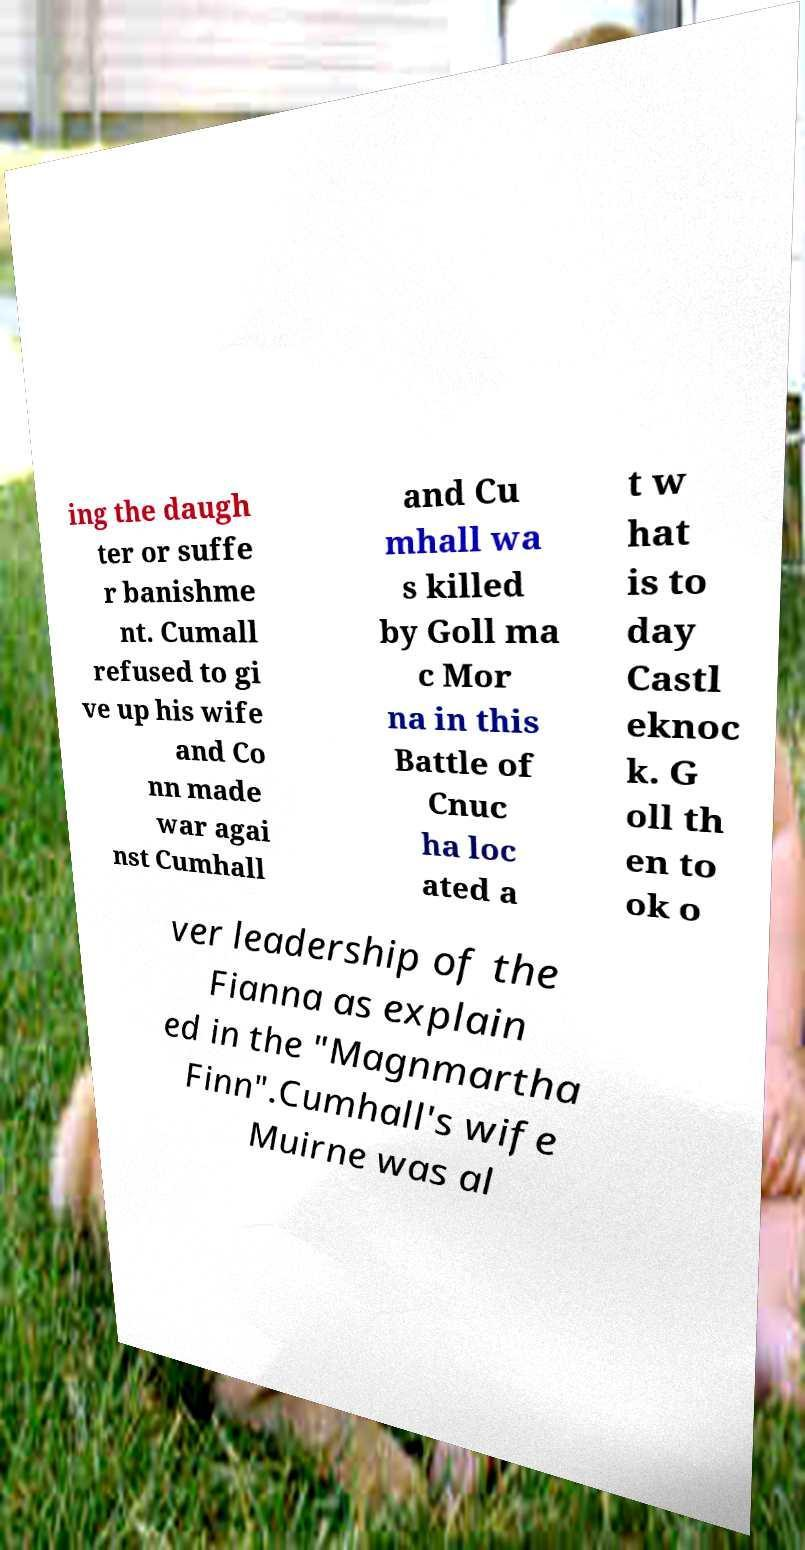There's text embedded in this image that I need extracted. Can you transcribe it verbatim? ing the daugh ter or suffe r banishme nt. Cumall refused to gi ve up his wife and Co nn made war agai nst Cumhall and Cu mhall wa s killed by Goll ma c Mor na in this Battle of Cnuc ha loc ated a t w hat is to day Castl eknoc k. G oll th en to ok o ver leadership of the Fianna as explain ed in the "Magnmartha Finn".Cumhall's wife Muirne was al 